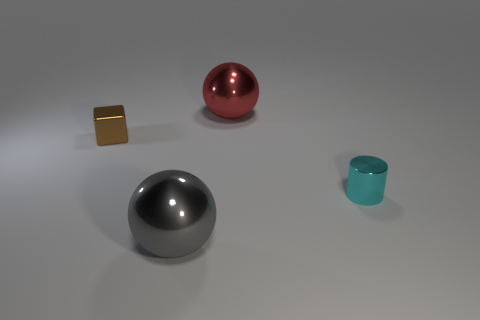Add 1 brown shiny cubes. How many objects exist? 5 Subtract all blocks. How many objects are left? 3 Subtract 0 blue cubes. How many objects are left? 4 Subtract all purple metallic cylinders. Subtract all big balls. How many objects are left? 2 Add 2 red shiny things. How many red shiny things are left? 3 Add 1 yellow metal blocks. How many yellow metal blocks exist? 1 